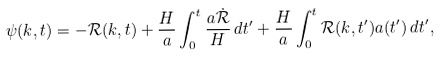Convert formula to latex. <formula><loc_0><loc_0><loc_500><loc_500>\psi ( k , t ) = - { \mathcal { R } } ( k , t ) + \frac { H } { a } \int _ { 0 } ^ { t } \frac { a \dot { \mathcal { R } } } { H } \, d t ^ { \prime } + \frac { H } { a } \int _ { 0 } ^ { t } { \mathcal { R } } ( k , t ^ { \prime } ) a ( t ^ { \prime } ) \, d t ^ { \prime } ,</formula> 